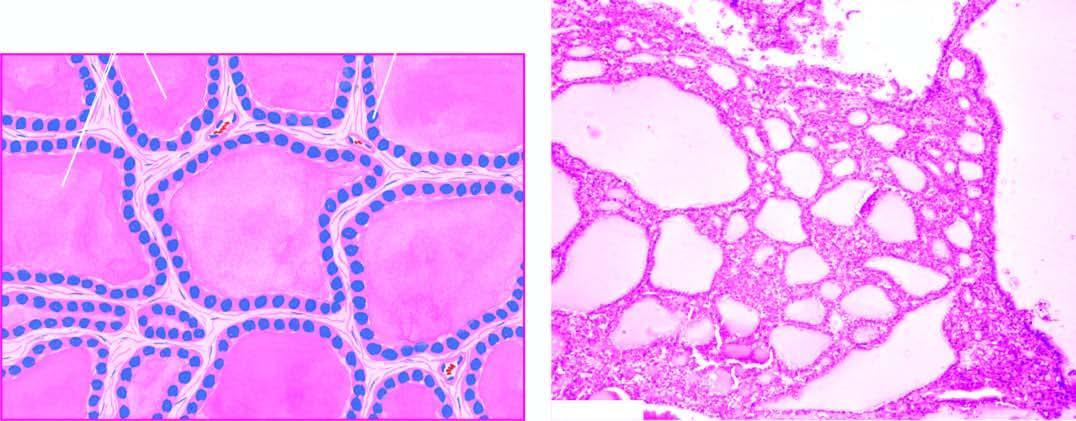does the sectioned surface show large follicles distended by colloid and lined by flattened follicular epithelium?
Answer the question using a single word or phrase. No 